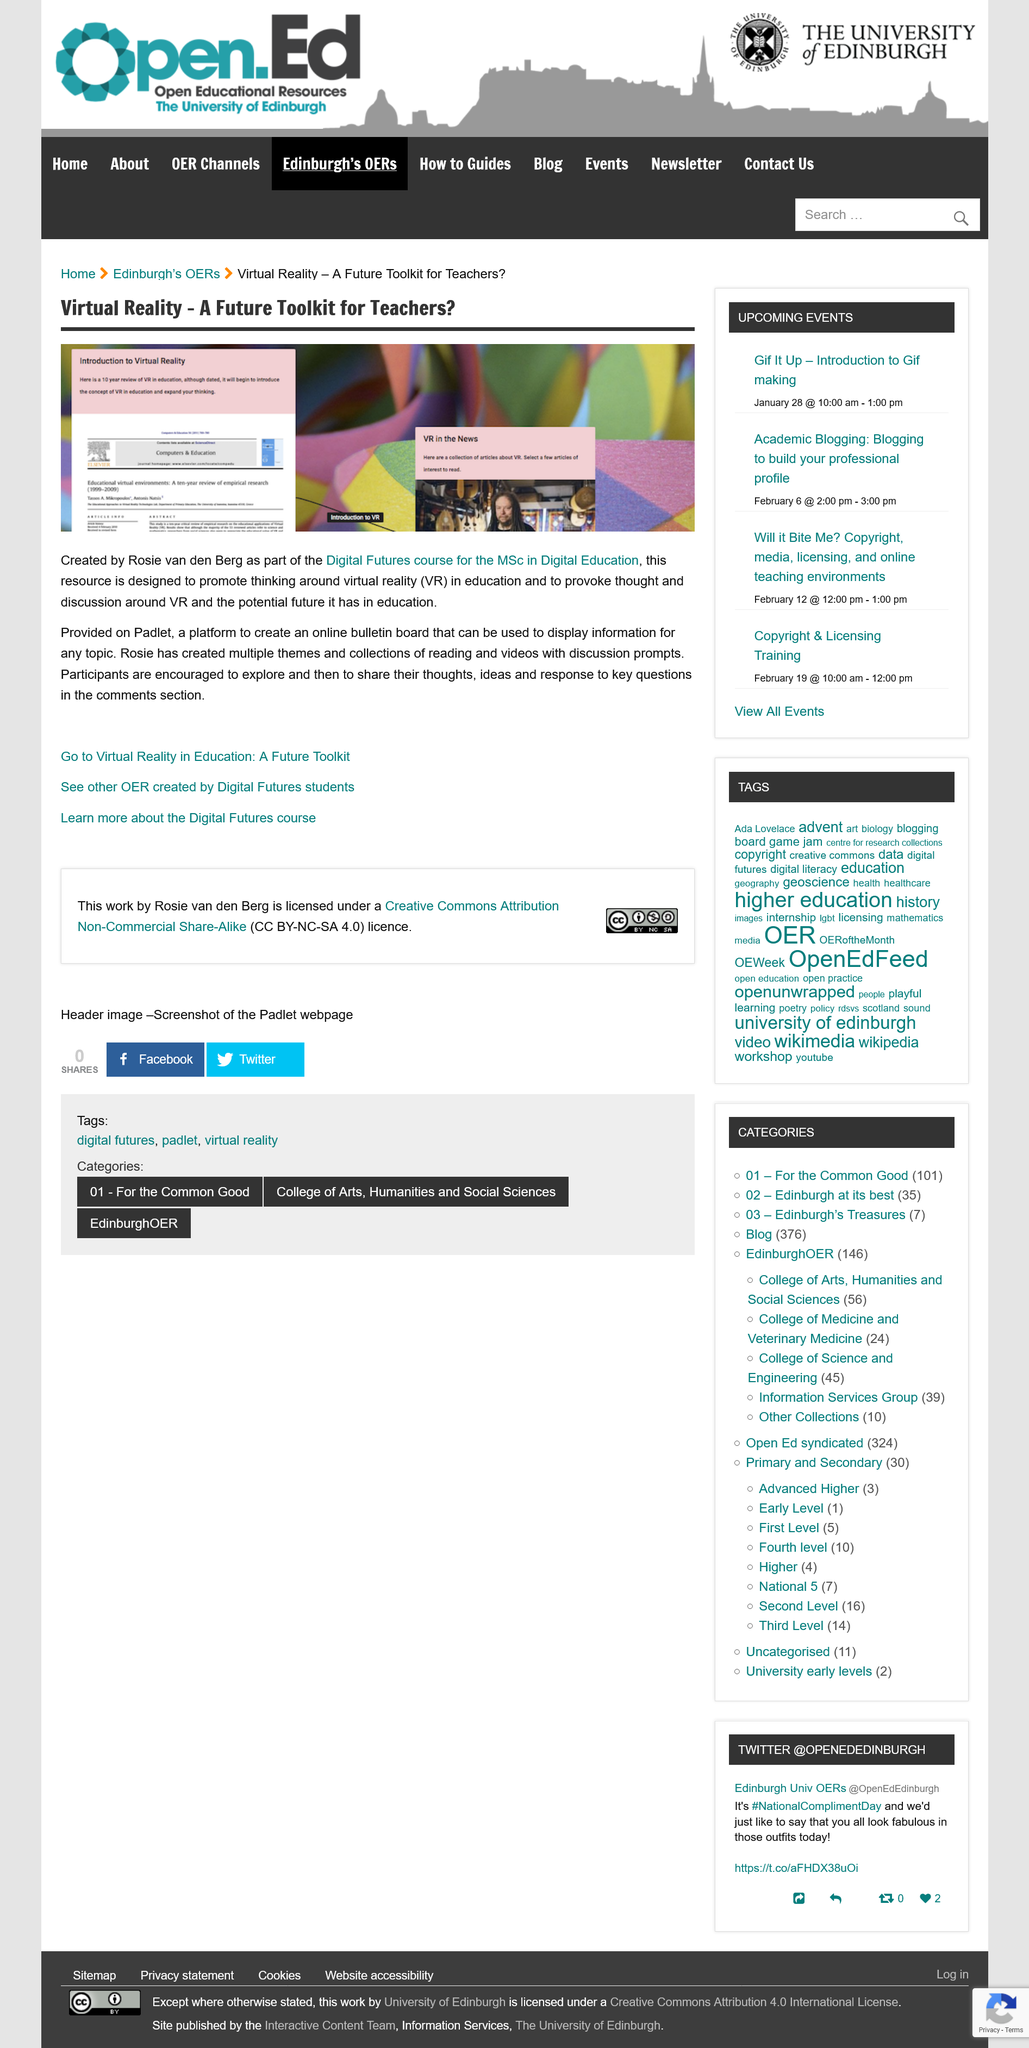Point out several critical features in this image. The resource was created by Rosie van den berg and participants are encouraged to share their experiences in the comments section. Virtual Reality is a term that refers to computer-generated simulated environments that can be experienced through sensory perception, providing a realistic experience that can simulate the real world. It is often used in the context of video games and other forms of entertainment, but it also has applications in fields such as education, training, and therapy. The Digital Futures course for the MSc in Digital Education is provided on Padlet. 